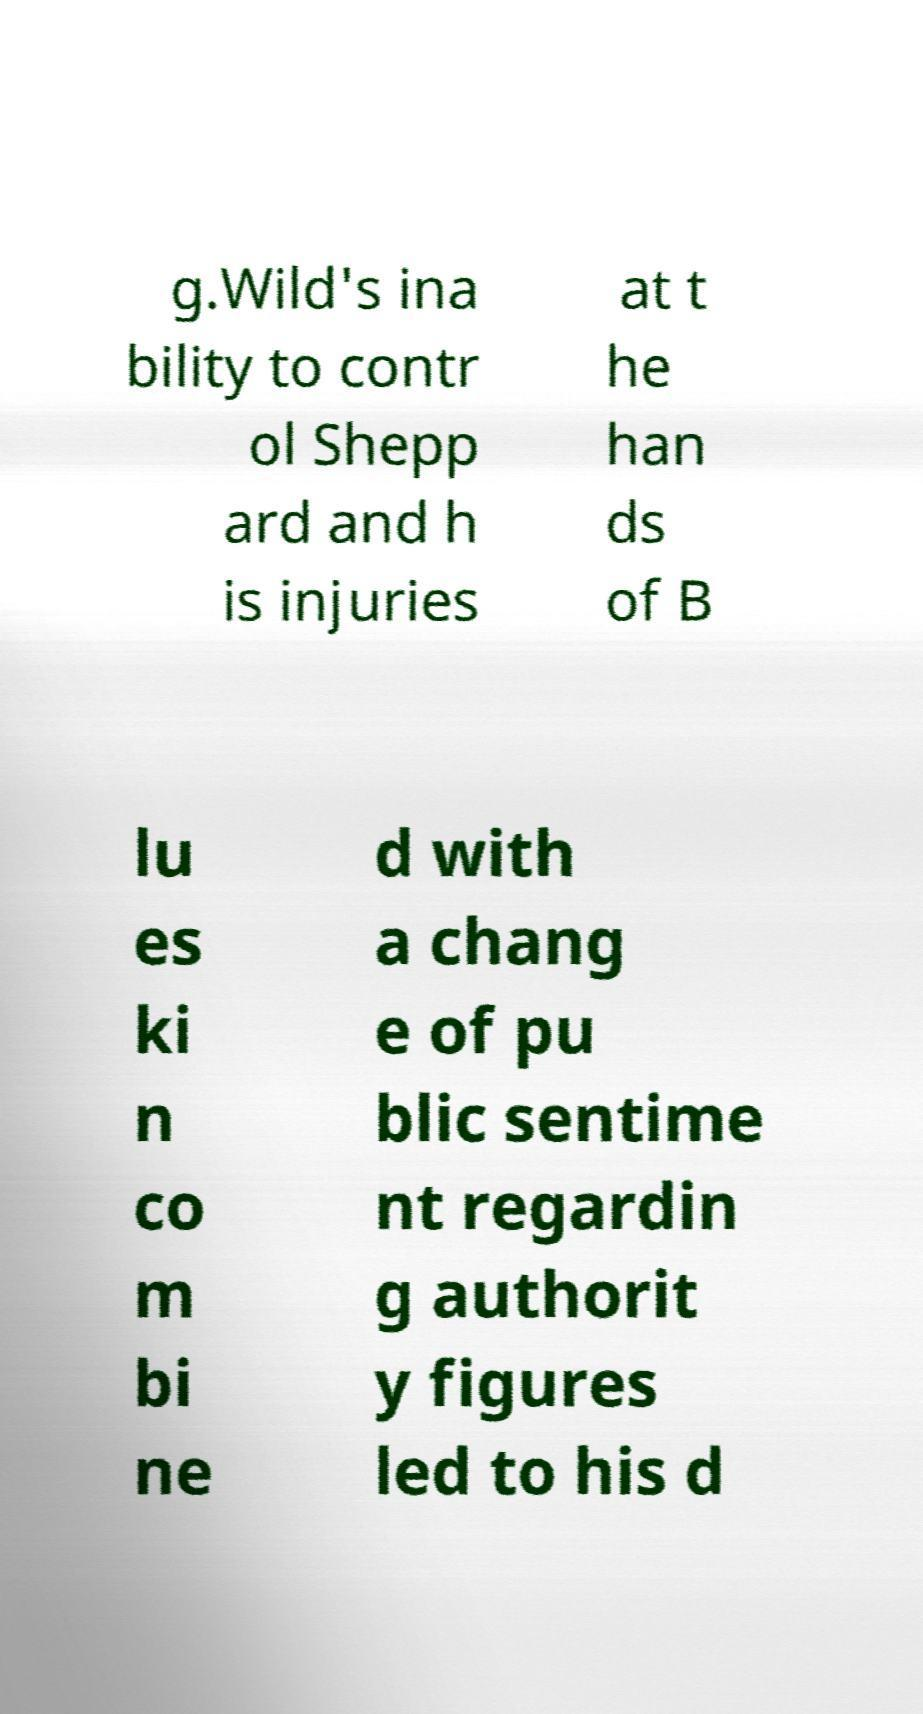Can you read and provide the text displayed in the image?This photo seems to have some interesting text. Can you extract and type it out for me? g.Wild's ina bility to contr ol Shepp ard and h is injuries at t he han ds of B lu es ki n co m bi ne d with a chang e of pu blic sentime nt regardin g authorit y figures led to his d 